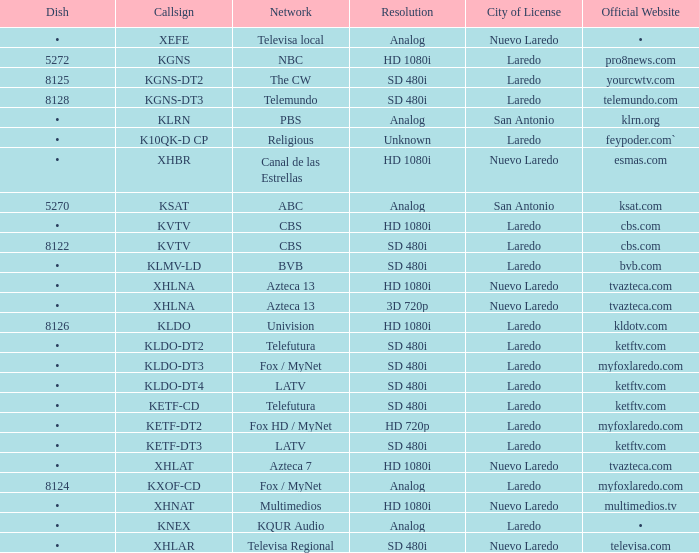Name the city of license with resolution of sd 480i and official website of telemundo.com Laredo. 